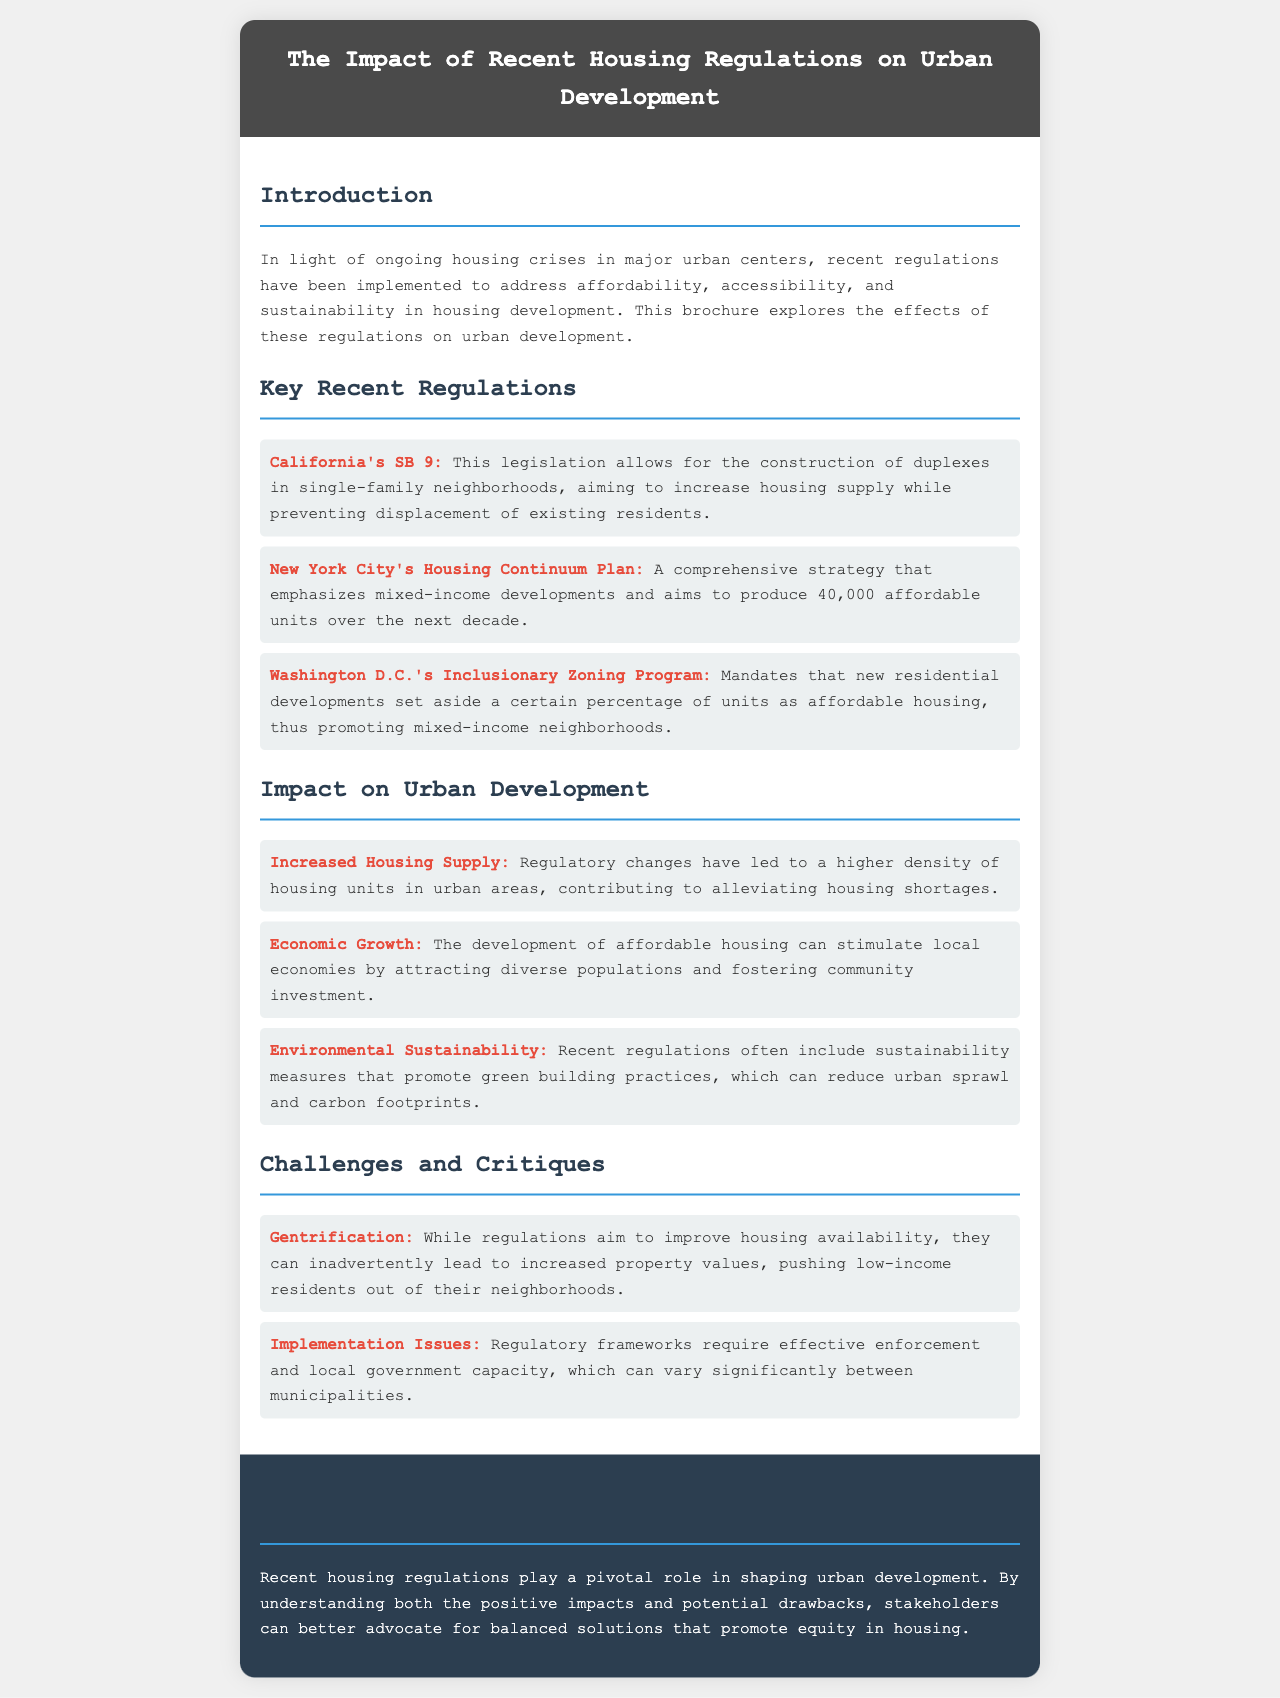What is the title of the brochure? The title is prominently displayed at the top of the document, which is "The Impact of Recent Housing Regulations on Urban Development."
Answer: The Impact of Recent Housing Regulations on Urban Development What regulation allows duplexes in single-family neighborhoods? The document lists California's SB 9 as the legislation that permits this, aimed at increasing housing supply.
Answer: California's SB 9 How many affordable units does New York City's Housing Continuum Plan aim to produce? The document specifies that the plan aims to produce 40,000 affordable units over the next decade.
Answer: 40,000 What is one challenge mentioned regarding recent housing regulations? The document discusses "Gentrification" as a challenge that can lead to increased property values, pushing low-income residents out.
Answer: Gentrification What positive impact do regulatory changes have on urban development? The document states that one positive impact is "Increased Housing Supply," leading to a higher density of housing units in urban areas.
Answer: Increased Housing Supply What does the Washington D.C.'s Inclusionary Zoning Program promote? The document highlights that the program mandates new residential developments to set aside a certain percentage of units as affordable housing.
Answer: Affordable housing What is emphasized in the conclusion regarding housing regulations? The conclusion states that understanding both the positive impacts and potential drawbacks is essential for stakeholders to advocate for balanced solutions.
Answer: Balanced solutions 